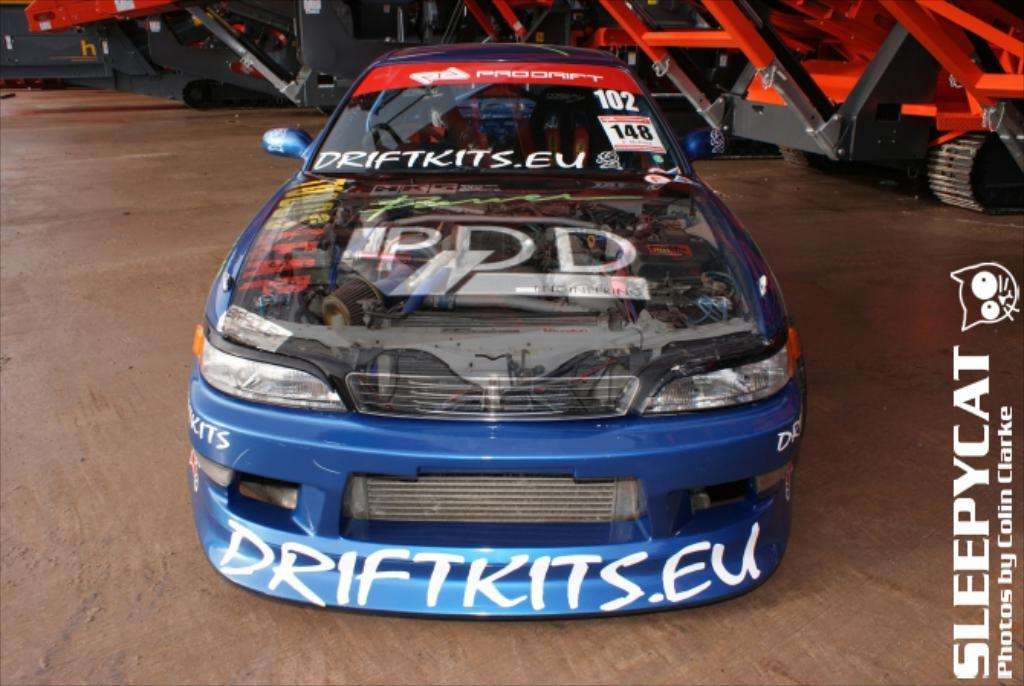What types of objects are present in the image? There are vehicles in the image. What can be seen beneath the vehicles? The ground is visible in the image. Where is the text located in the image? The text is on the right side of the image. What is the tendency of the silver bike in the image? There is no silver bike present in the image, so it's not possible to determine its tendency. 